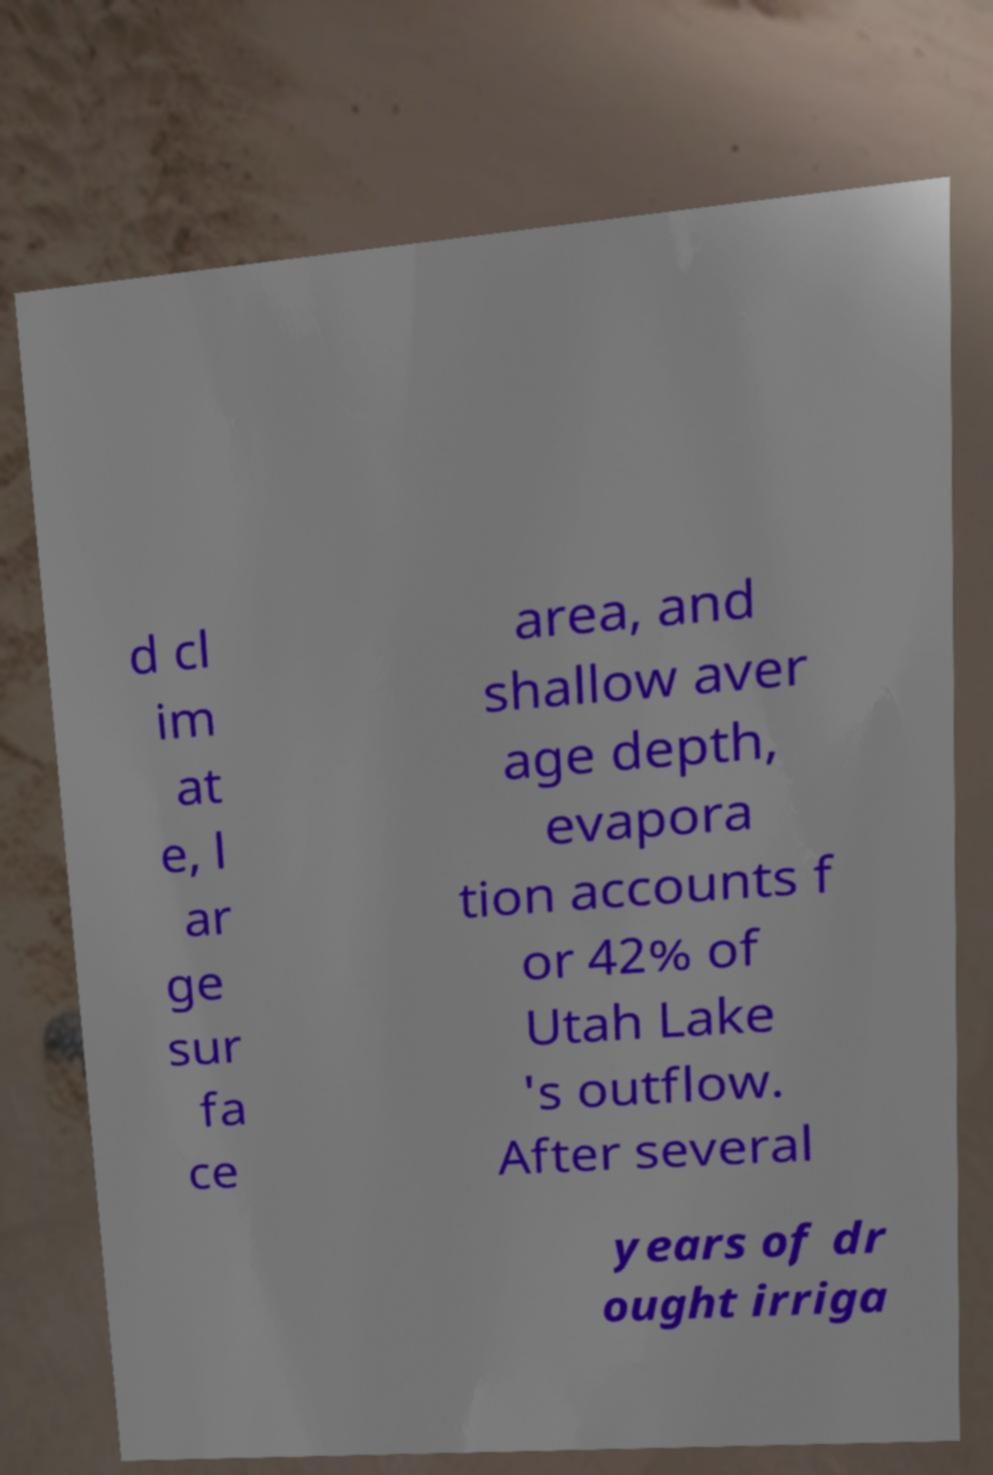Could you extract and type out the text from this image? d cl im at e, l ar ge sur fa ce area, and shallow aver age depth, evapora tion accounts f or 42% of Utah Lake 's outflow. After several years of dr ought irriga 